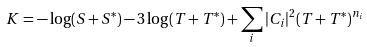<formula> <loc_0><loc_0><loc_500><loc_500>K = - \log ( S + S ^ { * } ) - 3 \log ( T + T ^ { * } ) + \sum _ { i } | C _ { i } | ^ { 2 } ( T + T ^ { * } ) ^ { n _ { i } }</formula> 